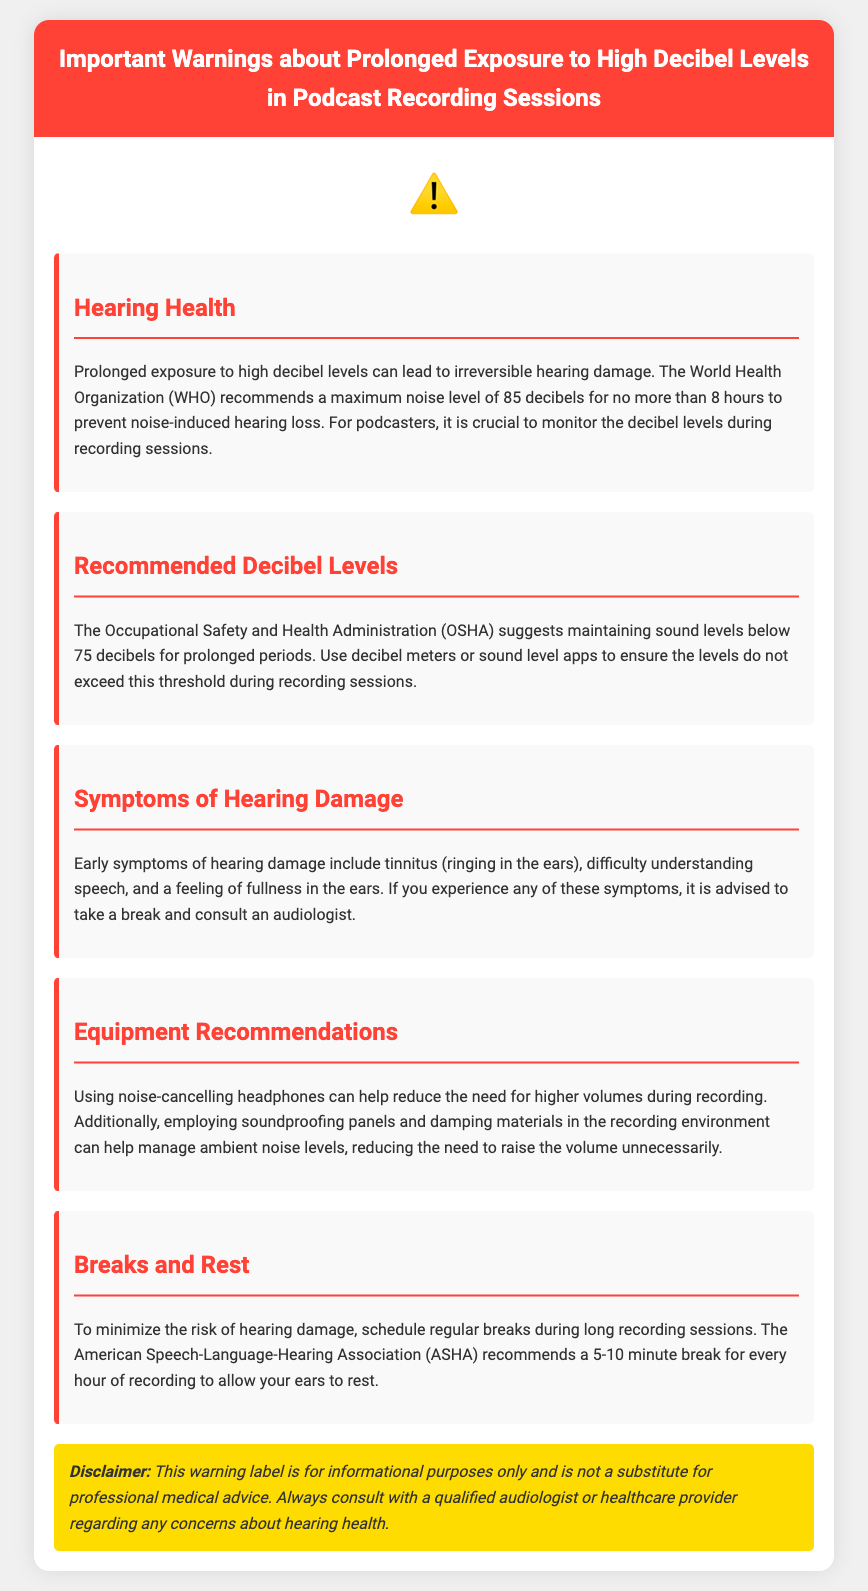What is the maximum noise level recommended by WHO? The World Health Organization (WHO) recommends a maximum noise level of 85 decibels to prevent noise-induced hearing loss.
Answer: 85 decibels What is the recommended sound level by OSHA for prolonged periods? The Occupational Safety and Health Administration (OSHA) suggests maintaining sound levels below 75 decibels for prolonged periods.
Answer: 75 decibels What are early symptoms of hearing damage? Early symptoms of hearing damage include tinnitus, difficulty understanding speech, and a feeling of fullness in the ears.
Answer: Tinnitus, difficulty understanding speech, feeling of fullness How long should breaks be during recording sessions? The American Speech-Language-Hearing Association (ASHA) recommends a 5-10 minute break for every hour of recording.
Answer: 5-10 minutes What type of headphones is recommended? Using noise-cancelling headphones can help reduce the need for higher volumes during recording.
Answer: Noise-cancelling headphones What is the purpose of this warning label? This warning label is for informational purposes only and is not a substitute for professional medical advice.
Answer: Informational purposes only Why should podcasters monitor decibel levels? It is crucial to monitor the decibel levels during recording sessions to prevent irreversible hearing damage.
Answer: To prevent irreversible hearing damage What should you do if you experience symptoms of hearing damage? If you experience any of these symptoms, it is advised to take a break and consult an audiologist.
Answer: Consult an audiologist 